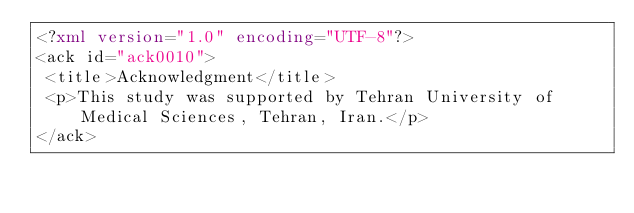<code> <loc_0><loc_0><loc_500><loc_500><_XML_><?xml version="1.0" encoding="UTF-8"?>
<ack id="ack0010">
 <title>Acknowledgment</title>
 <p>This study was supported by Tehran University of Medical Sciences, Tehran, Iran.</p>
</ack>
</code> 